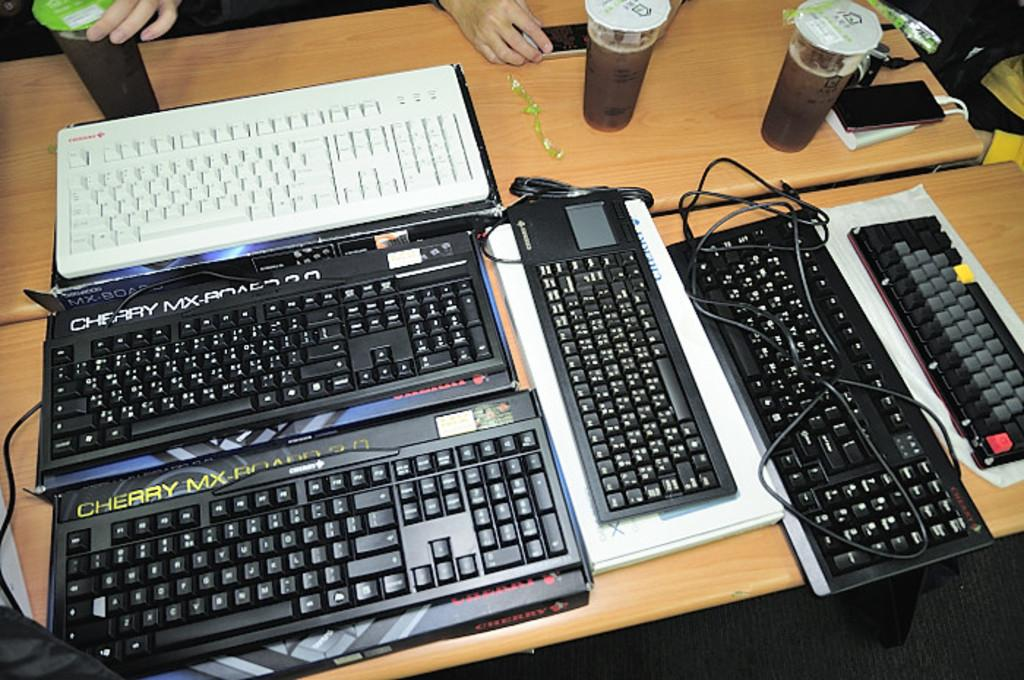What is the main piece of furniture in the image? There is a table in the image. What objects are placed on the table? Keyboards and coffee cups are present on the table. What type of communication device is on the table? A phone is on the table. What is used to charge the phone? A power bank is associated with the phone. What type of collar is visible on the expert in the image? There is no expert or collar present in the image. 